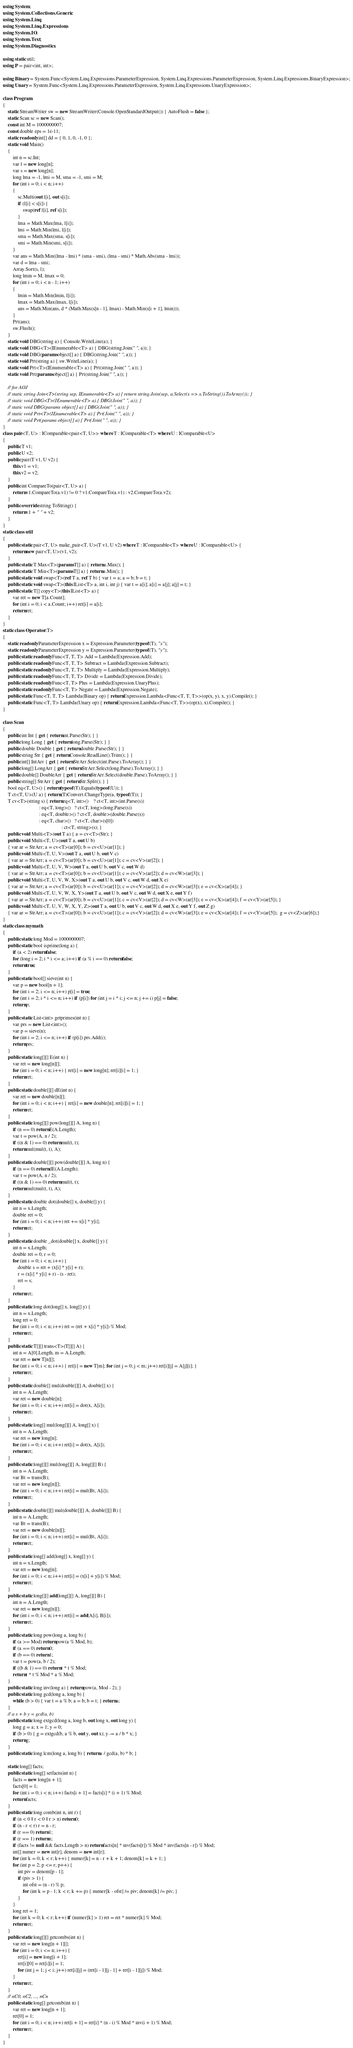<code> <loc_0><loc_0><loc_500><loc_500><_C#_>using System;
using System.Collections.Generic;
using System.Linq;
using System.Linq.Expressions;
using System.IO;
using System.Text;
using System.Diagnostics;

using static util;
using P = pair<int, int>;

using Binary = System.Func<System.Linq.Expressions.ParameterExpression, System.Linq.Expressions.ParameterExpression, System.Linq.Expressions.BinaryExpression>;
using Unary = System.Func<System.Linq.Expressions.ParameterExpression, System.Linq.Expressions.UnaryExpression>;

class Program
{
    static StreamWriter sw = new StreamWriter(Console.OpenStandardOutput()) { AutoFlush = false };
    static Scan sc = new Scan();
    const int M = 1000000007;
    const double eps = 1e-11;
    static readonly int[] dd = { 0, 1, 0, -1, 0 };
    static void Main()
    {
        int n = sc.Int;
        var l = new long[n];
        var s = new long[n];
        long lma = -1, lmi = M, sma = -1, smi = M;
        for (int i = 0; i < n; i++)
        {
            sc.Multi(out l[i], out s[i]);
            if (l[i] < s[i]) {
                swap(ref l[i], ref s[i]);
            }
            lma = Math.Max(lma, l[i]);
            lmi = Math.Min(lmi, l[i]);
            sma = Math.Max(sma, s[i]);
            smi = Math.Min(smi, s[i]);
        }
        var ans = Math.Min((lma - lmi) * (sma - smi), (lma - smi) * Math.Abs(sma - lmi));
        var d = lma - smi;
        Array.Sort(s, l);
        long lmin = M, lmax = 0;
        for (int i = 0; i < n - 1; i++)
        {
            lmin = Math.Min(lmin, l[i]);
            lmax = Math.Max(lmax, l[i]);
            ans = Math.Min(ans, d * (Math.Max(s[n - 1], lmax) - Math.Min(s[i + 1], lmin)));
        }
        Prt(ans);
        sw.Flush();
    }
    static void DBG(string a) { Console.WriteLine(a); }
    static void DBG<T>(IEnumerable<T> a) { DBG(string.Join(" ", a)); }
    static void DBG(params object[] a) { DBG(string.Join(" ", a)); }
    static void Prt(string a) { sw.WriteLine(a); }
    static void Prt<T>(IEnumerable<T> a) { Prt(string.Join(" ", a)); }
    static void Prt(params object[] a) { Prt(string.Join(" ", a)); }

    // for AOJ
    // static string Join<T>(string sep, IEnumerable<T> a) { return string.Join(sep, a.Select(x => x.ToString()).ToArray()); }
    // static void DBG<T>(IEnumerable<T> a) { DBG(Join(" ", a)); }
    // static void DBG(params object[] a) { DBG(Join(" ", a)); }
    // static void Prt<T>(IEnumerable<T> a) { Prt(Join(" ", a)); }
    // static void Prt(params object[] a) { Prt(Join(" ", a)); }
}
class pair<T, U> : IComparable<pair<T, U>> where T : IComparable<T> where U : IComparable<U>
{
    public T v1;
    public U v2;
    public pair(T v1, U v2) {
        this.v1 = v1;
        this.v2 = v2;
    }
    public int CompareTo(pair<T, U> a) {
        return v1.CompareTo(a.v1) != 0 ? v1.CompareTo(a.v1) : v2.CompareTo(a.v2);
    }
    public override string ToString() {
        return v1 + " " + v2;
    }
}
static class util
{
    public static pair<T, U> make_pair<T, U>(T v1, U v2) where T : IComparable<T> where U : IComparable<U> {
        return new pair<T, U>(v1, v2);
    }
    public static T Max<T>(params T[] a) { return a.Max(); }
    public static T Min<T>(params T[] a) { return a.Min(); }
    public static void swap<T>(ref T a, ref T b) { var t = a; a = b; b = t; }
    public static void swap<T>(this IList<T> a, int i, int j) { var t = a[i]; a[i] = a[j]; a[j] = t; }
    public static T[] copy<T>(this IList<T> a) {
        var ret = new T[a.Count];
        for (int i = 0; i < a.Count; i++) ret[i] = a[i];
        return ret;
    }
}
static class Operator<T>
{
    static readonly ParameterExpression x = Expression.Parameter(typeof(T), "x");
    static readonly ParameterExpression y = Expression.Parameter(typeof(T), "y");
    public static readonly Func<T, T, T> Add = Lambda(Expression.Add);
    public static readonly Func<T, T, T> Subtract = Lambda(Expression.Subtract);
    public static readonly Func<T, T, T> Multiply = Lambda(Expression.Multiply);
    public static readonly Func<T, T, T> Divide = Lambda(Expression.Divide);
    public static readonly Func<T, T> Plus = Lambda(Expression.UnaryPlus);
    public static readonly Func<T, T> Negate = Lambda(Expression.Negate);
    public static Func<T, T, T> Lambda(Binary op) { return Expression.Lambda<Func<T, T, T>>(op(x, y), x, y).Compile(); }
    public static Func<T, T> Lambda(Unary op) { return Expression.Lambda<Func<T, T>>(op(x), x).Compile(); }
}

class Scan
{
    public int Int { get { return int.Parse(Str); } }
    public long Long { get { return long.Parse(Str); } }
    public double Double { get { return double.Parse(Str); } }
    public string Str { get { return Console.ReadLine().Trim(); } }
    public int[] IntArr { get { return StrArr.Select(int.Parse).ToArray(); } }
    public long[] LongArr { get { return StrArr.Select(long.Parse).ToArray(); } }
    public double[] DoubleArr { get { return StrArr.Select(double.Parse).ToArray(); } }
    public string[] StrArr { get { return Str.Split(); } }
    bool eq<T, U>() { return typeof(T).Equals(typeof(U)); }
    T ct<T, U>(U a) { return (T)Convert.ChangeType(a, typeof(T)); }
    T cv<T>(string s) { return eq<T, int>()    ? ct<T, int>(int.Parse(s))
                             : eq<T, long>()   ? ct<T, long>(long.Parse(s))
                             : eq<T, double>() ? ct<T, double>(double.Parse(s))
                             : eq<T, char>()   ? ct<T, char>(s[0])
                                               : ct<T, string>(s); }
    public void Multi<T>(out T a) { a = cv<T>(Str); }
    public void Multi<T, U>(out T a, out U b)
    { var ar = StrArr; a = cv<T>(ar[0]); b = cv<U>(ar[1]); }
    public void Multi<T, U, V>(out T a, out U b, out V c)
    { var ar = StrArr; a = cv<T>(ar[0]); b = cv<U>(ar[1]); c = cv<V>(ar[2]); }
    public void Multi<T, U, V, W>(out T a, out U b, out V c, out W d)
    { var ar = StrArr; a = cv<T>(ar[0]); b = cv<U>(ar[1]); c = cv<V>(ar[2]); d = cv<W>(ar[3]); }
    public void Multi<T, U, V, W, X>(out T a, out U b, out V c, out W d, out X e)
    { var ar = StrArr; a = cv<T>(ar[0]); b = cv<U>(ar[1]); c = cv<V>(ar[2]); d = cv<W>(ar[3]); e = cv<X>(ar[4]); }
    public void Multi<T, U, V, W, X, Y>(out T a, out U b, out V c, out W d, out X e, out Y f)
    { var ar = StrArr; a = cv<T>(ar[0]); b = cv<U>(ar[1]); c = cv<V>(ar[2]); d = cv<W>(ar[3]); e = cv<X>(ar[4]); f = cv<Y>(ar[5]); }
    public void Multi<T, U, V, W, X, Y, Z>(out T a, out U b, out V c, out W d, out X e, out Y f, out Z g)
    { var ar = StrArr; a = cv<T>(ar[0]); b = cv<U>(ar[1]); c = cv<V>(ar[2]); d = cv<W>(ar[3]); e = cv<X>(ar[4]); f = cv<Y>(ar[5]);  g = cv<Z>(ar[6]);}
}
static class mymath
{
    public static long Mod = 1000000007;
    public static bool isprime(long a) {
        if (a < 2) return false;
        for (long i = 2; i * i <= a; i++) if (a % i == 0) return false;
        return true;
    }
    public static bool[] sieve(int n) {
        var p = new bool[n + 1];
        for (int i = 2; i <= n; i++) p[i] = true;
        for (int i = 2; i * i <= n; i++) if (p[i]) for (int j = i * i; j <= n; j += i) p[j] = false;
        return p;
    }
    public static List<int> getprimes(int n) {
        var prs = new List<int>();
        var p = sieve(n);
        for (int i = 2; i <= n; i++) if (p[i]) prs.Add(i);
        return prs;
    }
    public static long[][] E(int n) {
        var ret = new long[n][];
        for (int i = 0; i < n; i++) { ret[i] = new long[n]; ret[i][i] = 1; }
        return ret;
    }
    public static double[][] dE(int n) {
        var ret = new double[n][];
        for (int i = 0; i < n; i++) { ret[i] = new double[n]; ret[i][i] = 1; }
        return ret;
    }
    public static long[][] pow(long[][] A, long n) {
        if (n == 0) return E(A.Length);
        var t = pow(A, n / 2);
        if ((n & 1) == 0) return mul(t, t);
        return mul(mul(t, t), A);
    }
    public static double[][] pow(double[][] A, long n) {
        if (n == 0) return dE(A.Length);
        var t = pow(A, n / 2);
        if ((n & 1) == 0) return mul(t, t);
        return mul(mul(t, t), A);
    }
    public static double dot(double[] x, double[] y) {
        int n = x.Length;
        double ret = 0;
        for (int i = 0; i < n; i++) ret += x[i] * y[i];
        return ret;
    }
    public static double _dot(double[] x, double[] y) {
        int n = x.Length;
        double ret = 0, r = 0;
        for (int i = 0; i < n; i++) {
            double s = ret + (x[i] * y[i] + r);
            r = (x[i] * y[i] + r) - (s - ret);
            ret = s;
        }
        return ret;
    }
    public static long dot(long[] x, long[] y) {
        int n = x.Length;
        long ret = 0;
        for (int i = 0; i < n; i++) ret = (ret + x[i] * y[i]) % Mod;
        return ret;
    }
    public static T[][] trans<T>(T[][] A) {
        int n = A[0].Length, m = A.Length;
        var ret = new T[n][];
        for (int i = 0; i < n; i++) { ret[i] = new T[m]; for (int j = 0; j < m; j++) ret[i][j] = A[j][i]; }
        return ret;
    }
    public static double[] mul(double[][] A, double[] x) {
        int n = A.Length;
        var ret = new double[n];
        for (int i = 0; i < n; i++) ret[i] = dot(x, A[i]);
        return ret;
    }
    public static long[] mul(long[][] A, long[] x) {
        int n = A.Length;
        var ret = new long[n];
        for (int i = 0; i < n; i++) ret[i] = dot(x, A[i]);
        return ret;
    }
    public static long[][] mul(long[][] A, long[][] B) {
        int n = A.Length;
        var Bt = trans(B);
        var ret = new long[n][];
        for (int i = 0; i < n; i++) ret[i] = mul(Bt, A[i]);
        return ret;
    }
    public static double[][] mul(double[][] A, double[][] B) {
        int n = A.Length;
        var Bt = trans(B);
        var ret = new double[n][];
        for (int i = 0; i < n; i++) ret[i] = mul(Bt, A[i]);
        return ret;
    }
    public static long[] add(long[] x, long[] y) {
        int n = x.Length;
        var ret = new long[n];
        for (int i = 0; i < n; i++) ret[i] = (x[i] + y[i]) % Mod;
        return ret;
    }
    public static long[][] add(long[][] A, long[][] B) {
        int n = A.Length;
        var ret = new long[n][];
        for (int i = 0; i < n; i++) ret[i] = add(A[i], B[i]);
        return ret;
    }
    public static long pow(long a, long b) {
        if (a >= Mod) return pow(a % Mod, b);
        if (a == 0) return 0;
        if (b == 0) return 1;
        var t = pow(a, b / 2);
        if ((b & 1) == 0) return t * t % Mod;
        return t * t % Mod * a % Mod;
    }
    public static long inv(long a) { return pow(a, Mod - 2); }
    public static long gcd(long a, long b) {
        while (b > 0) { var t = a % b; a = b; b = t; } return a;
    }
    // a x + b y = gcd(a, b)
    public static long extgcd(long a, long b, out long x, out long y) {
        long g = a; x = 1; y = 0;
        if (b > 0) { g = extgcd(b, a % b, out y, out x); y -= a / b * x; }
        return g;
    }
    public static long lcm(long a, long b) { return a / gcd(a, b) * b; }

    static long[] facts;
    public static long[] setfacts(int n) {
        facts = new long[n + 1];
        facts[0] = 1;
        for (int i = 0; i < n; i++) facts[i + 1] = facts[i] * (i + 1) % Mod;
        return facts;
    }
    public static long comb(int n, int r) {
        if (n < 0 || r < 0 || r > n) return 0;
        if (n - r < r) r = n - r;
        if (r == 0) return 1;
        if (r == 1) return n;
        if (facts != null && facts.Length > n) return facts[n] * inv(facts[r]) % Mod * inv(facts[n - r]) % Mod;
        int[] numer = new int[r], denom = new int[r];
        for (int k = 0; k < r; k++) { numer[k] = n - r + k + 1; denom[k] = k + 1; }
        for (int p = 2; p <= r; p++) {
            int piv = denom[p - 1];
            if (piv > 1) {
                int ofst = (n - r) % p;
                for (int k = p - 1; k < r; k += p) { numer[k - ofst] /= piv; denom[k] /= piv; }
            }
        }
        long ret = 1;
        for (int k = 0; k < r; k++) if (numer[k] > 1) ret = ret * numer[k] % Mod;
        return ret;
    }
    public static long[][] getcombs(int n) {
        var ret = new long[n + 1][];
        for (int i = 0; i <= n; i++) {
            ret[i] = new long[i + 1];
            ret[i][0] = ret[i][i] = 1;
            for (int j = 1; j < i; j++) ret[i][j] = (ret[i - 1][j - 1] + ret[i - 1][j]) % Mod;
        }
        return ret;
    }
    // nC0, nC2, ..., nCn
    public static long[] getcomb(int n) {
        var ret = new long[n + 1];
        ret[0] = 1;
        for (int i = 0; i < n; i++) ret[i + 1] = ret[i] * (n - i) % Mod * inv(i + 1) % Mod;
        return ret;
    }
}
</code> 